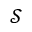<formula> <loc_0><loc_0><loc_500><loc_500>\ m a t h s c r { S }</formula> 